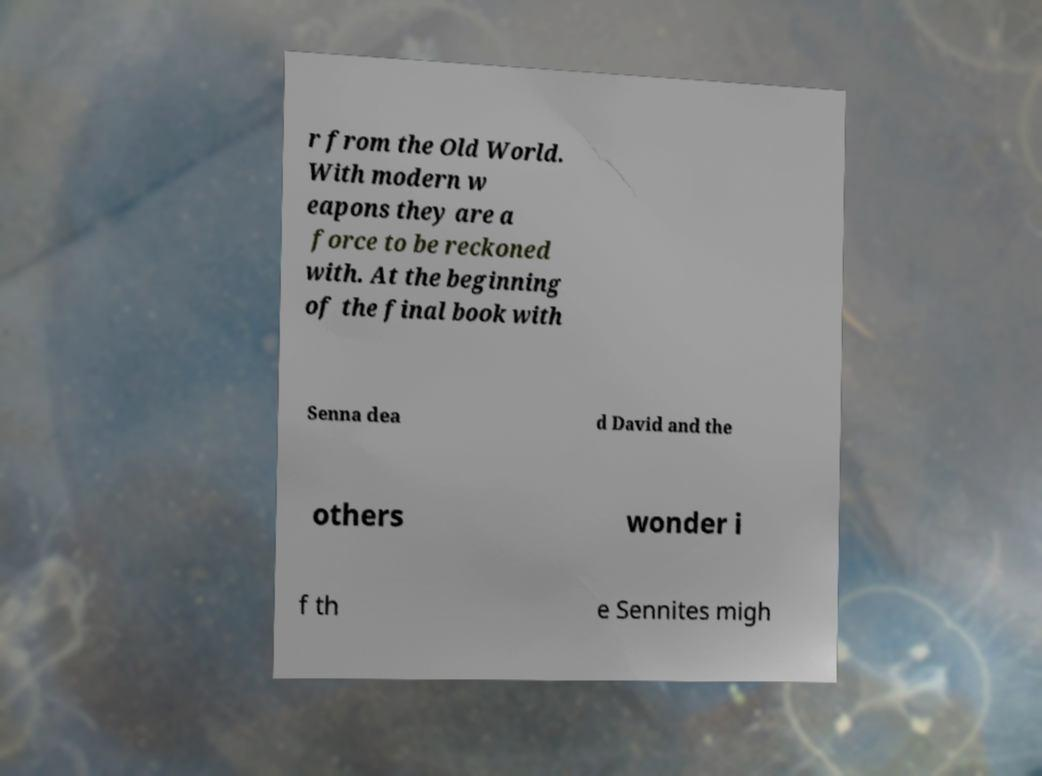I need the written content from this picture converted into text. Can you do that? r from the Old World. With modern w eapons they are a force to be reckoned with. At the beginning of the final book with Senna dea d David and the others wonder i f th e Sennites migh 